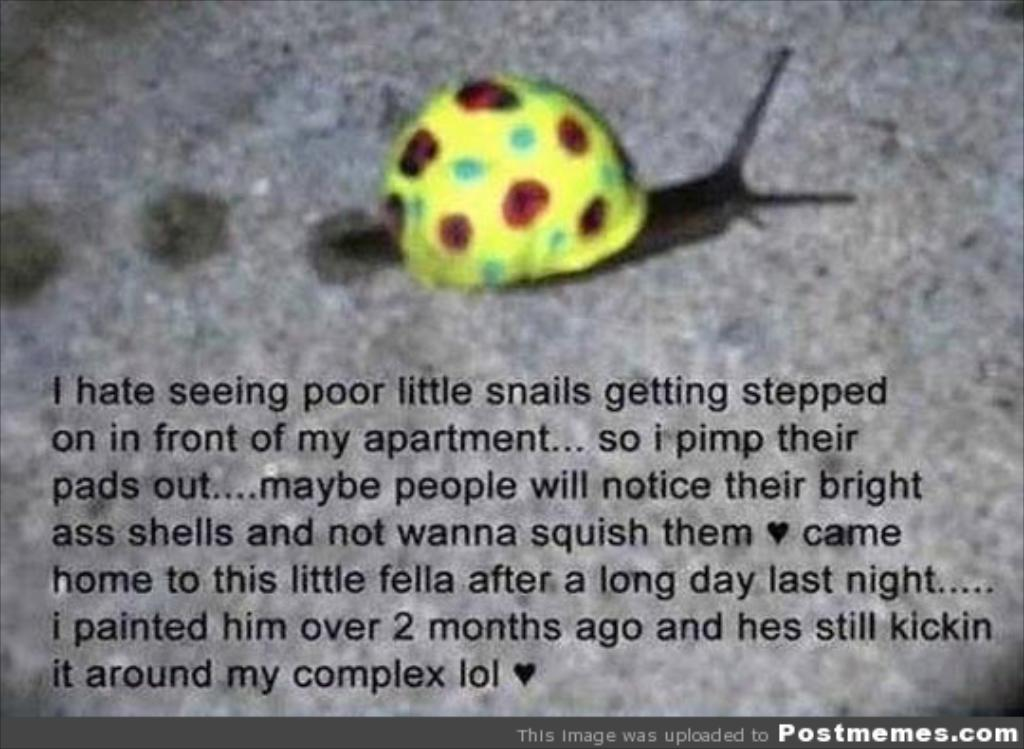What type of image is shown in the picture? The image appears to be a printed image. Can you describe anything on the floor in the image? There is an insect visible on the floor in the image. What else can be found in the image besides the insect? There is text present in the image. What type of prose is being recited by the insect in the image? There is no indication in the image that the insect is reciting any prose, as insects do not have the ability to speak or recite literature. 